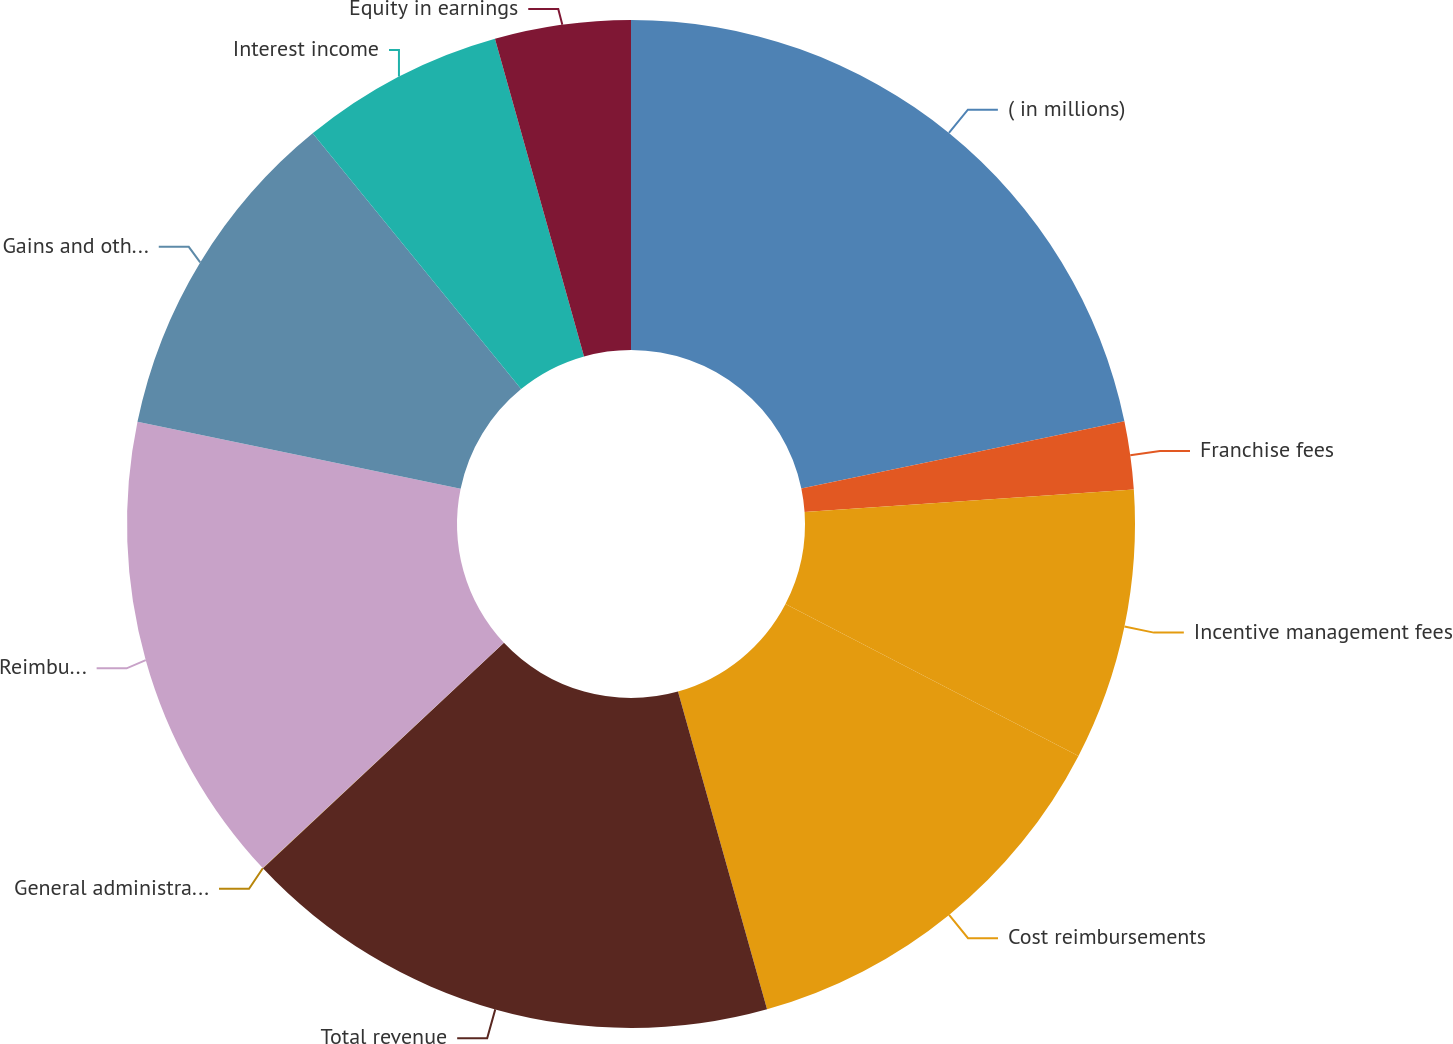Convert chart. <chart><loc_0><loc_0><loc_500><loc_500><pie_chart><fcel>( in millions)<fcel>Franchise fees<fcel>Incentive management fees<fcel>Cost reimbursements<fcel>Total revenue<fcel>General administrative and<fcel>Reimbursed costs<fcel>Gains and other income<fcel>Interest income<fcel>Equity in earnings<nl><fcel>21.73%<fcel>2.18%<fcel>8.7%<fcel>13.04%<fcel>17.38%<fcel>0.01%<fcel>15.21%<fcel>10.87%<fcel>6.53%<fcel>4.35%<nl></chart> 